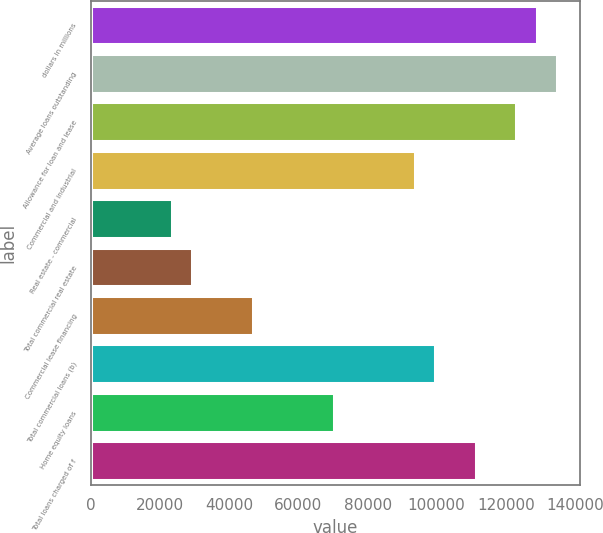Convert chart. <chart><loc_0><loc_0><loc_500><loc_500><bar_chart><fcel>dollars in millions<fcel>Average loans outstanding<fcel>Allowance for loan and lease<fcel>Commercial and industrial<fcel>Real estate - commercial<fcel>Total commercial real estate<fcel>Commercial lease financing<fcel>Total commercial loans (b)<fcel>Home equity loans<fcel>Total loans charged of f<nl><fcel>128906<fcel>134765<fcel>123046<fcel>93749.8<fcel>23438.2<fcel>29297.5<fcel>46875.4<fcel>99609.1<fcel>70312.6<fcel>111328<nl></chart> 